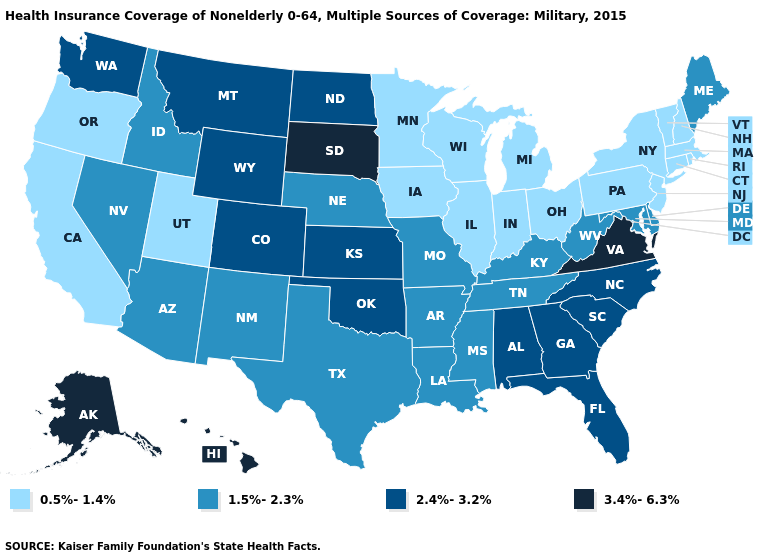How many symbols are there in the legend?
Concise answer only. 4. How many symbols are there in the legend?
Write a very short answer. 4. What is the value of Oregon?
Short answer required. 0.5%-1.4%. What is the lowest value in states that border Rhode Island?
Answer briefly. 0.5%-1.4%. What is the value of California?
Concise answer only. 0.5%-1.4%. Does Kansas have the lowest value in the MidWest?
Be succinct. No. Among the states that border Louisiana , which have the highest value?
Short answer required. Arkansas, Mississippi, Texas. What is the value of Alaska?
Keep it brief. 3.4%-6.3%. Name the states that have a value in the range 0.5%-1.4%?
Concise answer only. California, Connecticut, Illinois, Indiana, Iowa, Massachusetts, Michigan, Minnesota, New Hampshire, New Jersey, New York, Ohio, Oregon, Pennsylvania, Rhode Island, Utah, Vermont, Wisconsin. Among the states that border Idaho , which have the lowest value?
Answer briefly. Oregon, Utah. Does Indiana have the same value as West Virginia?
Give a very brief answer. No. What is the value of South Dakota?
Answer briefly. 3.4%-6.3%. What is the lowest value in the USA?
Give a very brief answer. 0.5%-1.4%. Which states have the lowest value in the USA?
Short answer required. California, Connecticut, Illinois, Indiana, Iowa, Massachusetts, Michigan, Minnesota, New Hampshire, New Jersey, New York, Ohio, Oregon, Pennsylvania, Rhode Island, Utah, Vermont, Wisconsin. 